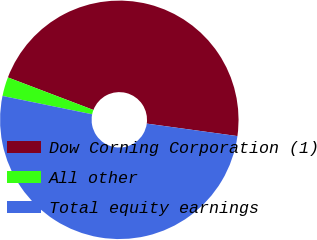<chart> <loc_0><loc_0><loc_500><loc_500><pie_chart><fcel>Dow Corning Corporation (1)<fcel>All other<fcel>Total equity earnings<nl><fcel>46.39%<fcel>2.58%<fcel>51.03%<nl></chart> 